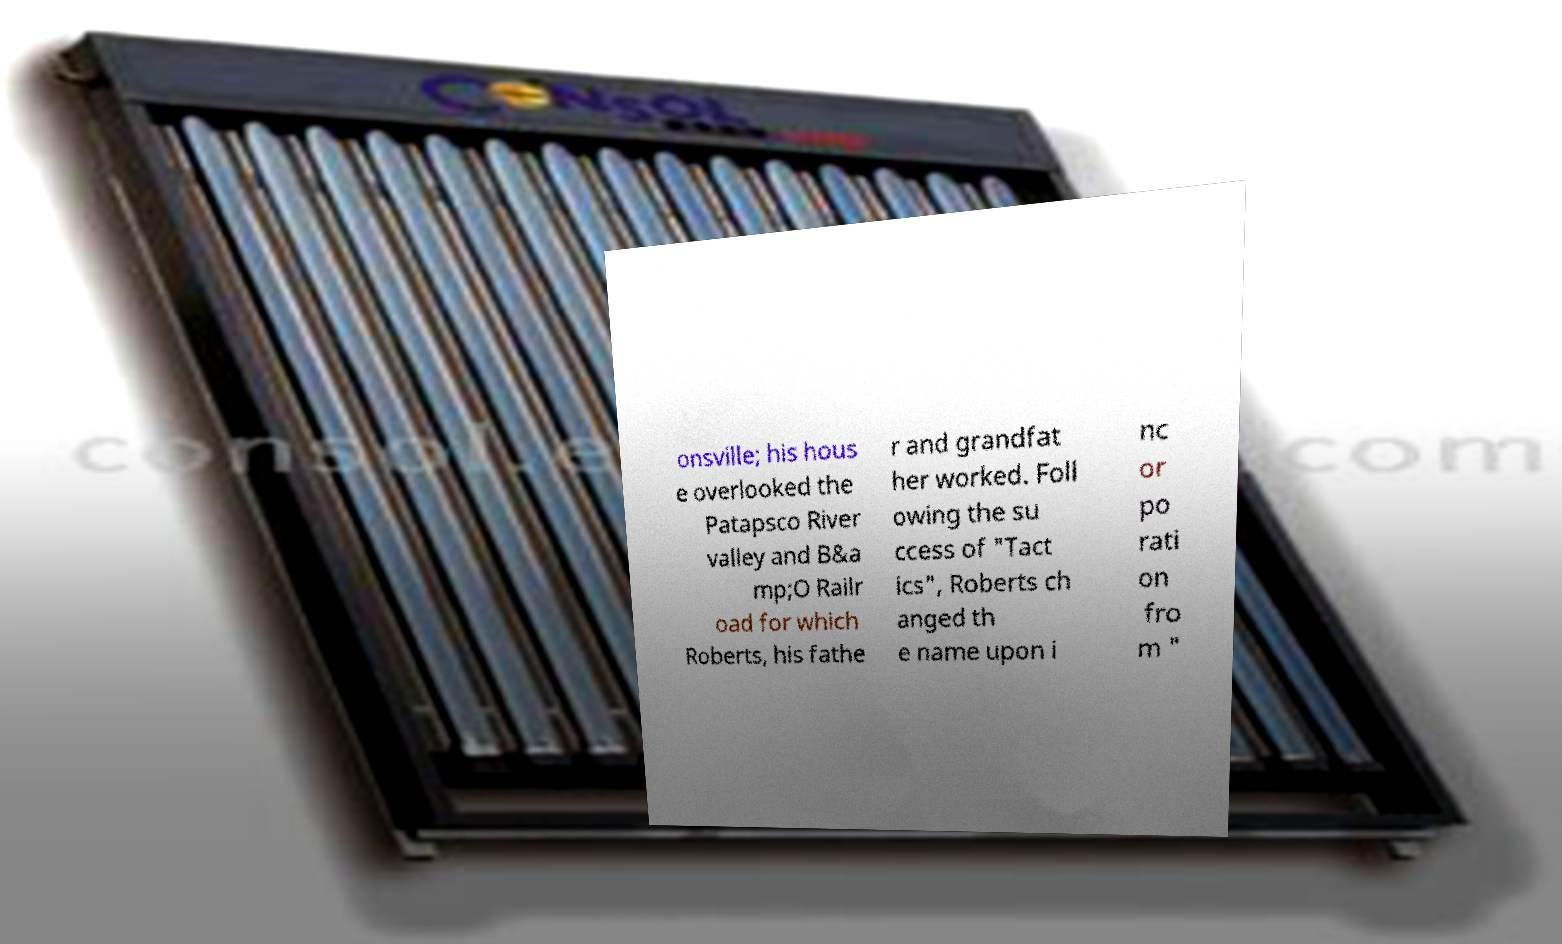There's text embedded in this image that I need extracted. Can you transcribe it verbatim? onsville; his hous e overlooked the Patapsco River valley and B&a mp;O Railr oad for which Roberts, his fathe r and grandfat her worked. Foll owing the su ccess of "Tact ics", Roberts ch anged th e name upon i nc or po rati on fro m " 